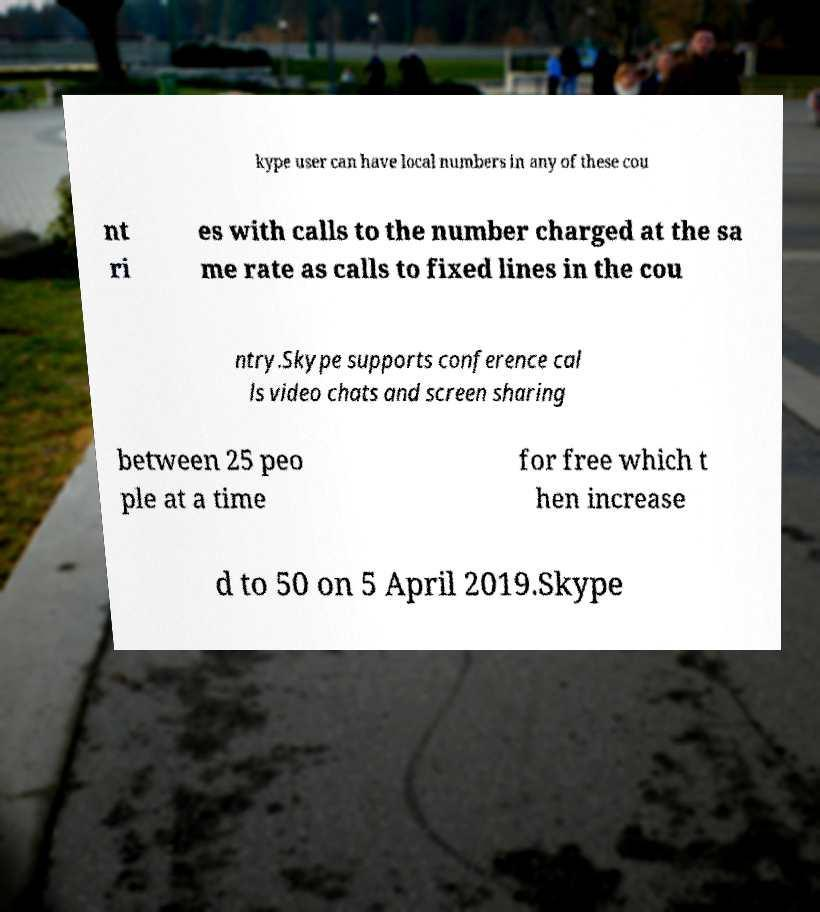Please read and relay the text visible in this image. What does it say? kype user can have local numbers in any of these cou nt ri es with calls to the number charged at the sa me rate as calls to fixed lines in the cou ntry.Skype supports conference cal ls video chats and screen sharing between 25 peo ple at a time for free which t hen increase d to 50 on 5 April 2019.Skype 